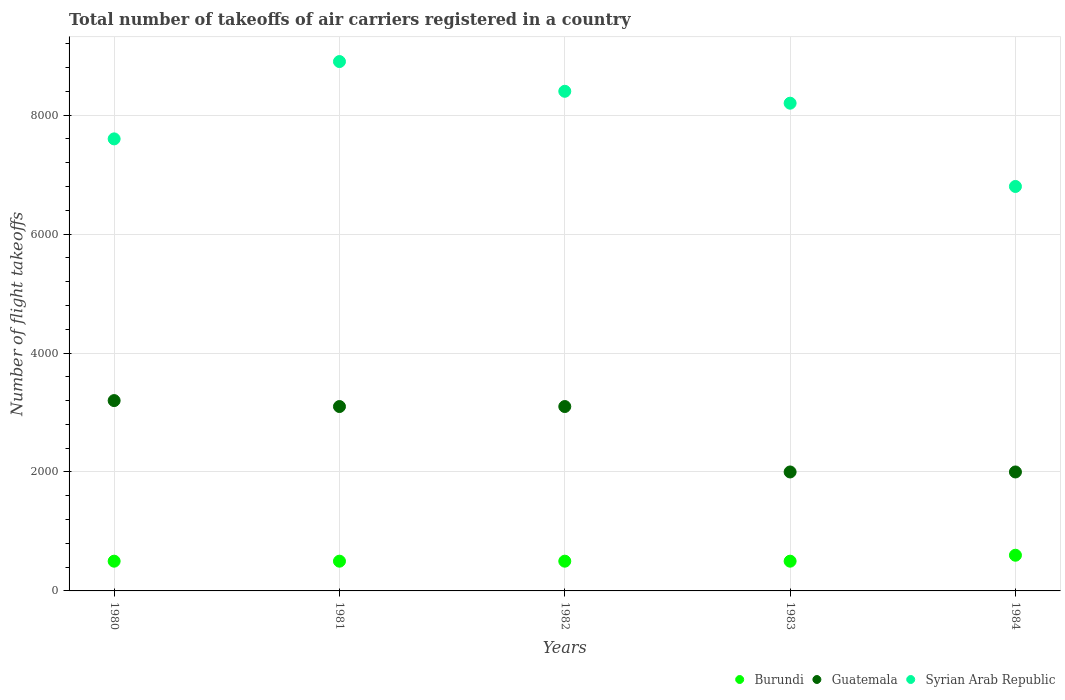What is the total number of flight takeoffs in Syrian Arab Republic in 1984?
Make the answer very short. 6800. Across all years, what is the maximum total number of flight takeoffs in Guatemala?
Give a very brief answer. 3200. Across all years, what is the minimum total number of flight takeoffs in Burundi?
Make the answer very short. 500. In which year was the total number of flight takeoffs in Burundi maximum?
Your response must be concise. 1984. What is the total total number of flight takeoffs in Burundi in the graph?
Give a very brief answer. 2600. What is the difference between the total number of flight takeoffs in Syrian Arab Republic in 1981 and that in 1983?
Keep it short and to the point. 700. What is the difference between the total number of flight takeoffs in Syrian Arab Republic in 1980 and the total number of flight takeoffs in Burundi in 1982?
Offer a terse response. 7100. What is the average total number of flight takeoffs in Syrian Arab Republic per year?
Keep it short and to the point. 7980. In the year 1980, what is the difference between the total number of flight takeoffs in Guatemala and total number of flight takeoffs in Syrian Arab Republic?
Keep it short and to the point. -4400. In how many years, is the total number of flight takeoffs in Guatemala greater than 5200?
Make the answer very short. 0. Is the total number of flight takeoffs in Burundi in 1981 less than that in 1982?
Ensure brevity in your answer.  No. What is the difference between the highest and the lowest total number of flight takeoffs in Guatemala?
Keep it short and to the point. 1200. In how many years, is the total number of flight takeoffs in Syrian Arab Republic greater than the average total number of flight takeoffs in Syrian Arab Republic taken over all years?
Offer a terse response. 3. How many dotlines are there?
Provide a succinct answer. 3. How many years are there in the graph?
Keep it short and to the point. 5. What is the difference between two consecutive major ticks on the Y-axis?
Give a very brief answer. 2000. Does the graph contain grids?
Offer a very short reply. Yes. Where does the legend appear in the graph?
Give a very brief answer. Bottom right. What is the title of the graph?
Your answer should be very brief. Total number of takeoffs of air carriers registered in a country. What is the label or title of the Y-axis?
Offer a very short reply. Number of flight takeoffs. What is the Number of flight takeoffs in Guatemala in 1980?
Make the answer very short. 3200. What is the Number of flight takeoffs in Syrian Arab Republic in 1980?
Your answer should be compact. 7600. What is the Number of flight takeoffs of Burundi in 1981?
Your answer should be compact. 500. What is the Number of flight takeoffs in Guatemala in 1981?
Offer a terse response. 3100. What is the Number of flight takeoffs of Syrian Arab Republic in 1981?
Give a very brief answer. 8900. What is the Number of flight takeoffs of Guatemala in 1982?
Offer a very short reply. 3100. What is the Number of flight takeoffs of Syrian Arab Republic in 1982?
Provide a succinct answer. 8400. What is the Number of flight takeoffs in Burundi in 1983?
Make the answer very short. 500. What is the Number of flight takeoffs in Guatemala in 1983?
Offer a very short reply. 2000. What is the Number of flight takeoffs in Syrian Arab Republic in 1983?
Your response must be concise. 8200. What is the Number of flight takeoffs in Burundi in 1984?
Make the answer very short. 600. What is the Number of flight takeoffs of Guatemala in 1984?
Offer a very short reply. 2000. What is the Number of flight takeoffs in Syrian Arab Republic in 1984?
Your answer should be very brief. 6800. Across all years, what is the maximum Number of flight takeoffs in Burundi?
Your response must be concise. 600. Across all years, what is the maximum Number of flight takeoffs of Guatemala?
Offer a terse response. 3200. Across all years, what is the maximum Number of flight takeoffs of Syrian Arab Republic?
Your response must be concise. 8900. Across all years, what is the minimum Number of flight takeoffs in Syrian Arab Republic?
Offer a very short reply. 6800. What is the total Number of flight takeoffs in Burundi in the graph?
Offer a very short reply. 2600. What is the total Number of flight takeoffs of Guatemala in the graph?
Your answer should be compact. 1.34e+04. What is the total Number of flight takeoffs of Syrian Arab Republic in the graph?
Ensure brevity in your answer.  3.99e+04. What is the difference between the Number of flight takeoffs of Burundi in 1980 and that in 1981?
Make the answer very short. 0. What is the difference between the Number of flight takeoffs in Guatemala in 1980 and that in 1981?
Keep it short and to the point. 100. What is the difference between the Number of flight takeoffs of Syrian Arab Republic in 1980 and that in 1981?
Your answer should be very brief. -1300. What is the difference between the Number of flight takeoffs in Syrian Arab Republic in 1980 and that in 1982?
Offer a terse response. -800. What is the difference between the Number of flight takeoffs of Burundi in 1980 and that in 1983?
Offer a terse response. 0. What is the difference between the Number of flight takeoffs in Guatemala in 1980 and that in 1983?
Keep it short and to the point. 1200. What is the difference between the Number of flight takeoffs of Syrian Arab Republic in 1980 and that in 1983?
Offer a very short reply. -600. What is the difference between the Number of flight takeoffs in Burundi in 1980 and that in 1984?
Offer a very short reply. -100. What is the difference between the Number of flight takeoffs in Guatemala in 1980 and that in 1984?
Your answer should be compact. 1200. What is the difference between the Number of flight takeoffs in Syrian Arab Republic in 1980 and that in 1984?
Your answer should be compact. 800. What is the difference between the Number of flight takeoffs of Guatemala in 1981 and that in 1982?
Make the answer very short. 0. What is the difference between the Number of flight takeoffs in Syrian Arab Republic in 1981 and that in 1982?
Provide a short and direct response. 500. What is the difference between the Number of flight takeoffs in Guatemala in 1981 and that in 1983?
Offer a very short reply. 1100. What is the difference between the Number of flight takeoffs in Syrian Arab Republic in 1981 and that in 1983?
Offer a terse response. 700. What is the difference between the Number of flight takeoffs in Burundi in 1981 and that in 1984?
Keep it short and to the point. -100. What is the difference between the Number of flight takeoffs of Guatemala in 1981 and that in 1984?
Give a very brief answer. 1100. What is the difference between the Number of flight takeoffs of Syrian Arab Republic in 1981 and that in 1984?
Ensure brevity in your answer.  2100. What is the difference between the Number of flight takeoffs in Burundi in 1982 and that in 1983?
Your response must be concise. 0. What is the difference between the Number of flight takeoffs of Guatemala in 1982 and that in 1983?
Your answer should be compact. 1100. What is the difference between the Number of flight takeoffs in Syrian Arab Republic in 1982 and that in 1983?
Give a very brief answer. 200. What is the difference between the Number of flight takeoffs in Burundi in 1982 and that in 1984?
Ensure brevity in your answer.  -100. What is the difference between the Number of flight takeoffs of Guatemala in 1982 and that in 1984?
Your answer should be compact. 1100. What is the difference between the Number of flight takeoffs of Syrian Arab Republic in 1982 and that in 1984?
Your response must be concise. 1600. What is the difference between the Number of flight takeoffs in Burundi in 1983 and that in 1984?
Offer a terse response. -100. What is the difference between the Number of flight takeoffs of Syrian Arab Republic in 1983 and that in 1984?
Offer a very short reply. 1400. What is the difference between the Number of flight takeoffs of Burundi in 1980 and the Number of flight takeoffs of Guatemala in 1981?
Give a very brief answer. -2600. What is the difference between the Number of flight takeoffs in Burundi in 1980 and the Number of flight takeoffs in Syrian Arab Republic in 1981?
Your answer should be compact. -8400. What is the difference between the Number of flight takeoffs in Guatemala in 1980 and the Number of flight takeoffs in Syrian Arab Republic in 1981?
Your answer should be very brief. -5700. What is the difference between the Number of flight takeoffs in Burundi in 1980 and the Number of flight takeoffs in Guatemala in 1982?
Keep it short and to the point. -2600. What is the difference between the Number of flight takeoffs of Burundi in 1980 and the Number of flight takeoffs of Syrian Arab Republic in 1982?
Your answer should be compact. -7900. What is the difference between the Number of flight takeoffs in Guatemala in 1980 and the Number of flight takeoffs in Syrian Arab Republic in 1982?
Make the answer very short. -5200. What is the difference between the Number of flight takeoffs in Burundi in 1980 and the Number of flight takeoffs in Guatemala in 1983?
Your answer should be very brief. -1500. What is the difference between the Number of flight takeoffs of Burundi in 1980 and the Number of flight takeoffs of Syrian Arab Republic in 1983?
Offer a very short reply. -7700. What is the difference between the Number of flight takeoffs of Guatemala in 1980 and the Number of flight takeoffs of Syrian Arab Republic in 1983?
Ensure brevity in your answer.  -5000. What is the difference between the Number of flight takeoffs of Burundi in 1980 and the Number of flight takeoffs of Guatemala in 1984?
Offer a terse response. -1500. What is the difference between the Number of flight takeoffs in Burundi in 1980 and the Number of flight takeoffs in Syrian Arab Republic in 1984?
Make the answer very short. -6300. What is the difference between the Number of flight takeoffs in Guatemala in 1980 and the Number of flight takeoffs in Syrian Arab Republic in 1984?
Give a very brief answer. -3600. What is the difference between the Number of flight takeoffs in Burundi in 1981 and the Number of flight takeoffs in Guatemala in 1982?
Make the answer very short. -2600. What is the difference between the Number of flight takeoffs in Burundi in 1981 and the Number of flight takeoffs in Syrian Arab Republic in 1982?
Offer a terse response. -7900. What is the difference between the Number of flight takeoffs of Guatemala in 1981 and the Number of flight takeoffs of Syrian Arab Republic in 1982?
Your response must be concise. -5300. What is the difference between the Number of flight takeoffs in Burundi in 1981 and the Number of flight takeoffs in Guatemala in 1983?
Keep it short and to the point. -1500. What is the difference between the Number of flight takeoffs of Burundi in 1981 and the Number of flight takeoffs of Syrian Arab Republic in 1983?
Provide a short and direct response. -7700. What is the difference between the Number of flight takeoffs in Guatemala in 1981 and the Number of flight takeoffs in Syrian Arab Republic in 1983?
Offer a very short reply. -5100. What is the difference between the Number of flight takeoffs in Burundi in 1981 and the Number of flight takeoffs in Guatemala in 1984?
Give a very brief answer. -1500. What is the difference between the Number of flight takeoffs in Burundi in 1981 and the Number of flight takeoffs in Syrian Arab Republic in 1984?
Your response must be concise. -6300. What is the difference between the Number of flight takeoffs in Guatemala in 1981 and the Number of flight takeoffs in Syrian Arab Republic in 1984?
Your answer should be very brief. -3700. What is the difference between the Number of flight takeoffs in Burundi in 1982 and the Number of flight takeoffs in Guatemala in 1983?
Provide a short and direct response. -1500. What is the difference between the Number of flight takeoffs of Burundi in 1982 and the Number of flight takeoffs of Syrian Arab Republic in 1983?
Provide a short and direct response. -7700. What is the difference between the Number of flight takeoffs of Guatemala in 1982 and the Number of flight takeoffs of Syrian Arab Republic in 1983?
Keep it short and to the point. -5100. What is the difference between the Number of flight takeoffs of Burundi in 1982 and the Number of flight takeoffs of Guatemala in 1984?
Your answer should be compact. -1500. What is the difference between the Number of flight takeoffs of Burundi in 1982 and the Number of flight takeoffs of Syrian Arab Republic in 1984?
Give a very brief answer. -6300. What is the difference between the Number of flight takeoffs of Guatemala in 1982 and the Number of flight takeoffs of Syrian Arab Republic in 1984?
Keep it short and to the point. -3700. What is the difference between the Number of flight takeoffs of Burundi in 1983 and the Number of flight takeoffs of Guatemala in 1984?
Offer a terse response. -1500. What is the difference between the Number of flight takeoffs of Burundi in 1983 and the Number of flight takeoffs of Syrian Arab Republic in 1984?
Your response must be concise. -6300. What is the difference between the Number of flight takeoffs in Guatemala in 1983 and the Number of flight takeoffs in Syrian Arab Republic in 1984?
Provide a succinct answer. -4800. What is the average Number of flight takeoffs in Burundi per year?
Keep it short and to the point. 520. What is the average Number of flight takeoffs of Guatemala per year?
Provide a succinct answer. 2680. What is the average Number of flight takeoffs in Syrian Arab Republic per year?
Ensure brevity in your answer.  7980. In the year 1980, what is the difference between the Number of flight takeoffs in Burundi and Number of flight takeoffs in Guatemala?
Give a very brief answer. -2700. In the year 1980, what is the difference between the Number of flight takeoffs of Burundi and Number of flight takeoffs of Syrian Arab Republic?
Offer a very short reply. -7100. In the year 1980, what is the difference between the Number of flight takeoffs of Guatemala and Number of flight takeoffs of Syrian Arab Republic?
Give a very brief answer. -4400. In the year 1981, what is the difference between the Number of flight takeoffs of Burundi and Number of flight takeoffs of Guatemala?
Offer a terse response. -2600. In the year 1981, what is the difference between the Number of flight takeoffs in Burundi and Number of flight takeoffs in Syrian Arab Republic?
Offer a terse response. -8400. In the year 1981, what is the difference between the Number of flight takeoffs in Guatemala and Number of flight takeoffs in Syrian Arab Republic?
Your answer should be compact. -5800. In the year 1982, what is the difference between the Number of flight takeoffs in Burundi and Number of flight takeoffs in Guatemala?
Give a very brief answer. -2600. In the year 1982, what is the difference between the Number of flight takeoffs in Burundi and Number of flight takeoffs in Syrian Arab Republic?
Offer a terse response. -7900. In the year 1982, what is the difference between the Number of flight takeoffs in Guatemala and Number of flight takeoffs in Syrian Arab Republic?
Make the answer very short. -5300. In the year 1983, what is the difference between the Number of flight takeoffs of Burundi and Number of flight takeoffs of Guatemala?
Ensure brevity in your answer.  -1500. In the year 1983, what is the difference between the Number of flight takeoffs of Burundi and Number of flight takeoffs of Syrian Arab Republic?
Your response must be concise. -7700. In the year 1983, what is the difference between the Number of flight takeoffs of Guatemala and Number of flight takeoffs of Syrian Arab Republic?
Make the answer very short. -6200. In the year 1984, what is the difference between the Number of flight takeoffs of Burundi and Number of flight takeoffs of Guatemala?
Provide a succinct answer. -1400. In the year 1984, what is the difference between the Number of flight takeoffs in Burundi and Number of flight takeoffs in Syrian Arab Republic?
Keep it short and to the point. -6200. In the year 1984, what is the difference between the Number of flight takeoffs of Guatemala and Number of flight takeoffs of Syrian Arab Republic?
Make the answer very short. -4800. What is the ratio of the Number of flight takeoffs in Guatemala in 1980 to that in 1981?
Give a very brief answer. 1.03. What is the ratio of the Number of flight takeoffs in Syrian Arab Republic in 1980 to that in 1981?
Your answer should be very brief. 0.85. What is the ratio of the Number of flight takeoffs in Burundi in 1980 to that in 1982?
Your answer should be compact. 1. What is the ratio of the Number of flight takeoffs of Guatemala in 1980 to that in 1982?
Make the answer very short. 1.03. What is the ratio of the Number of flight takeoffs of Syrian Arab Republic in 1980 to that in 1982?
Provide a short and direct response. 0.9. What is the ratio of the Number of flight takeoffs in Burundi in 1980 to that in 1983?
Give a very brief answer. 1. What is the ratio of the Number of flight takeoffs of Guatemala in 1980 to that in 1983?
Keep it short and to the point. 1.6. What is the ratio of the Number of flight takeoffs in Syrian Arab Republic in 1980 to that in 1983?
Offer a very short reply. 0.93. What is the ratio of the Number of flight takeoffs of Burundi in 1980 to that in 1984?
Keep it short and to the point. 0.83. What is the ratio of the Number of flight takeoffs of Guatemala in 1980 to that in 1984?
Provide a succinct answer. 1.6. What is the ratio of the Number of flight takeoffs in Syrian Arab Republic in 1980 to that in 1984?
Offer a very short reply. 1.12. What is the ratio of the Number of flight takeoffs in Burundi in 1981 to that in 1982?
Your response must be concise. 1. What is the ratio of the Number of flight takeoffs in Syrian Arab Republic in 1981 to that in 1982?
Your response must be concise. 1.06. What is the ratio of the Number of flight takeoffs of Burundi in 1981 to that in 1983?
Your answer should be very brief. 1. What is the ratio of the Number of flight takeoffs in Guatemala in 1981 to that in 1983?
Your response must be concise. 1.55. What is the ratio of the Number of flight takeoffs in Syrian Arab Republic in 1981 to that in 1983?
Offer a very short reply. 1.09. What is the ratio of the Number of flight takeoffs in Guatemala in 1981 to that in 1984?
Ensure brevity in your answer.  1.55. What is the ratio of the Number of flight takeoffs in Syrian Arab Republic in 1981 to that in 1984?
Ensure brevity in your answer.  1.31. What is the ratio of the Number of flight takeoffs of Guatemala in 1982 to that in 1983?
Your response must be concise. 1.55. What is the ratio of the Number of flight takeoffs of Syrian Arab Republic in 1982 to that in 1983?
Keep it short and to the point. 1.02. What is the ratio of the Number of flight takeoffs in Burundi in 1982 to that in 1984?
Provide a succinct answer. 0.83. What is the ratio of the Number of flight takeoffs of Guatemala in 1982 to that in 1984?
Give a very brief answer. 1.55. What is the ratio of the Number of flight takeoffs in Syrian Arab Republic in 1982 to that in 1984?
Give a very brief answer. 1.24. What is the ratio of the Number of flight takeoffs in Guatemala in 1983 to that in 1984?
Your answer should be very brief. 1. What is the ratio of the Number of flight takeoffs in Syrian Arab Republic in 1983 to that in 1984?
Provide a succinct answer. 1.21. What is the difference between the highest and the second highest Number of flight takeoffs of Burundi?
Your answer should be compact. 100. What is the difference between the highest and the second highest Number of flight takeoffs in Guatemala?
Your answer should be compact. 100. What is the difference between the highest and the lowest Number of flight takeoffs in Guatemala?
Provide a succinct answer. 1200. What is the difference between the highest and the lowest Number of flight takeoffs of Syrian Arab Republic?
Keep it short and to the point. 2100. 